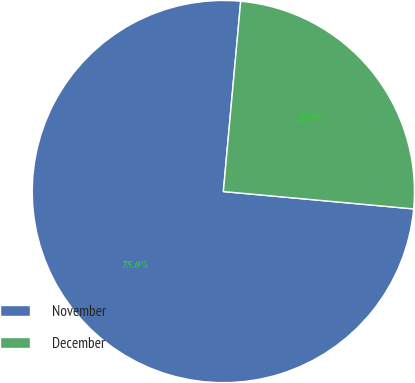Convert chart. <chart><loc_0><loc_0><loc_500><loc_500><pie_chart><fcel>November<fcel>December<nl><fcel>75.0%<fcel>25.0%<nl></chart> 